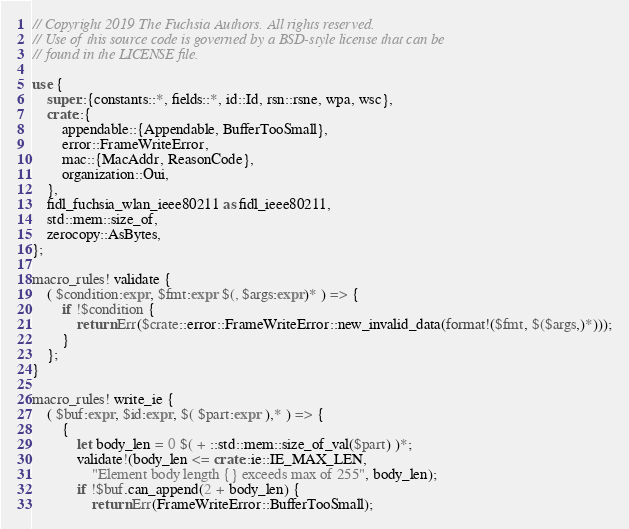Convert code to text. <code><loc_0><loc_0><loc_500><loc_500><_Rust_>// Copyright 2019 The Fuchsia Authors. All rights reserved.
// Use of this source code is governed by a BSD-style license that can be
// found in the LICENSE file.

use {
    super::{constants::*, fields::*, id::Id, rsn::rsne, wpa, wsc},
    crate::{
        appendable::{Appendable, BufferTooSmall},
        error::FrameWriteError,
        mac::{MacAddr, ReasonCode},
        organization::Oui,
    },
    fidl_fuchsia_wlan_ieee80211 as fidl_ieee80211,
    std::mem::size_of,
    zerocopy::AsBytes,
};

macro_rules! validate {
    ( $condition:expr, $fmt:expr $(, $args:expr)* ) => {
        if !$condition {
            return Err($crate::error::FrameWriteError::new_invalid_data(format!($fmt, $($args,)*)));
        }
    };
}

macro_rules! write_ie {
    ( $buf:expr, $id:expr, $( $part:expr ),* ) => {
        {
            let body_len = 0 $( + ::std::mem::size_of_val($part) )*;
            validate!(body_len <= crate::ie::IE_MAX_LEN,
                "Element body length {} exceeds max of 255", body_len);
            if !$buf.can_append(2 + body_len) {
                return Err(FrameWriteError::BufferTooSmall);</code> 